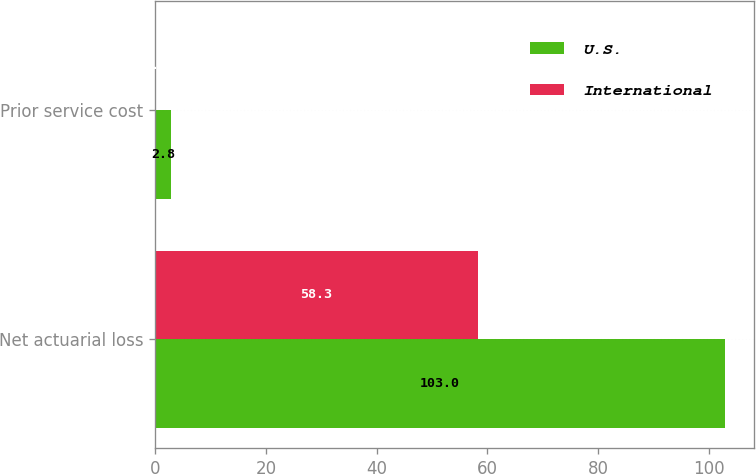<chart> <loc_0><loc_0><loc_500><loc_500><stacked_bar_chart><ecel><fcel>Net actuarial loss<fcel>Prior service cost<nl><fcel>U.S.<fcel>103<fcel>2.8<nl><fcel>International<fcel>58.3<fcel>0.2<nl></chart> 